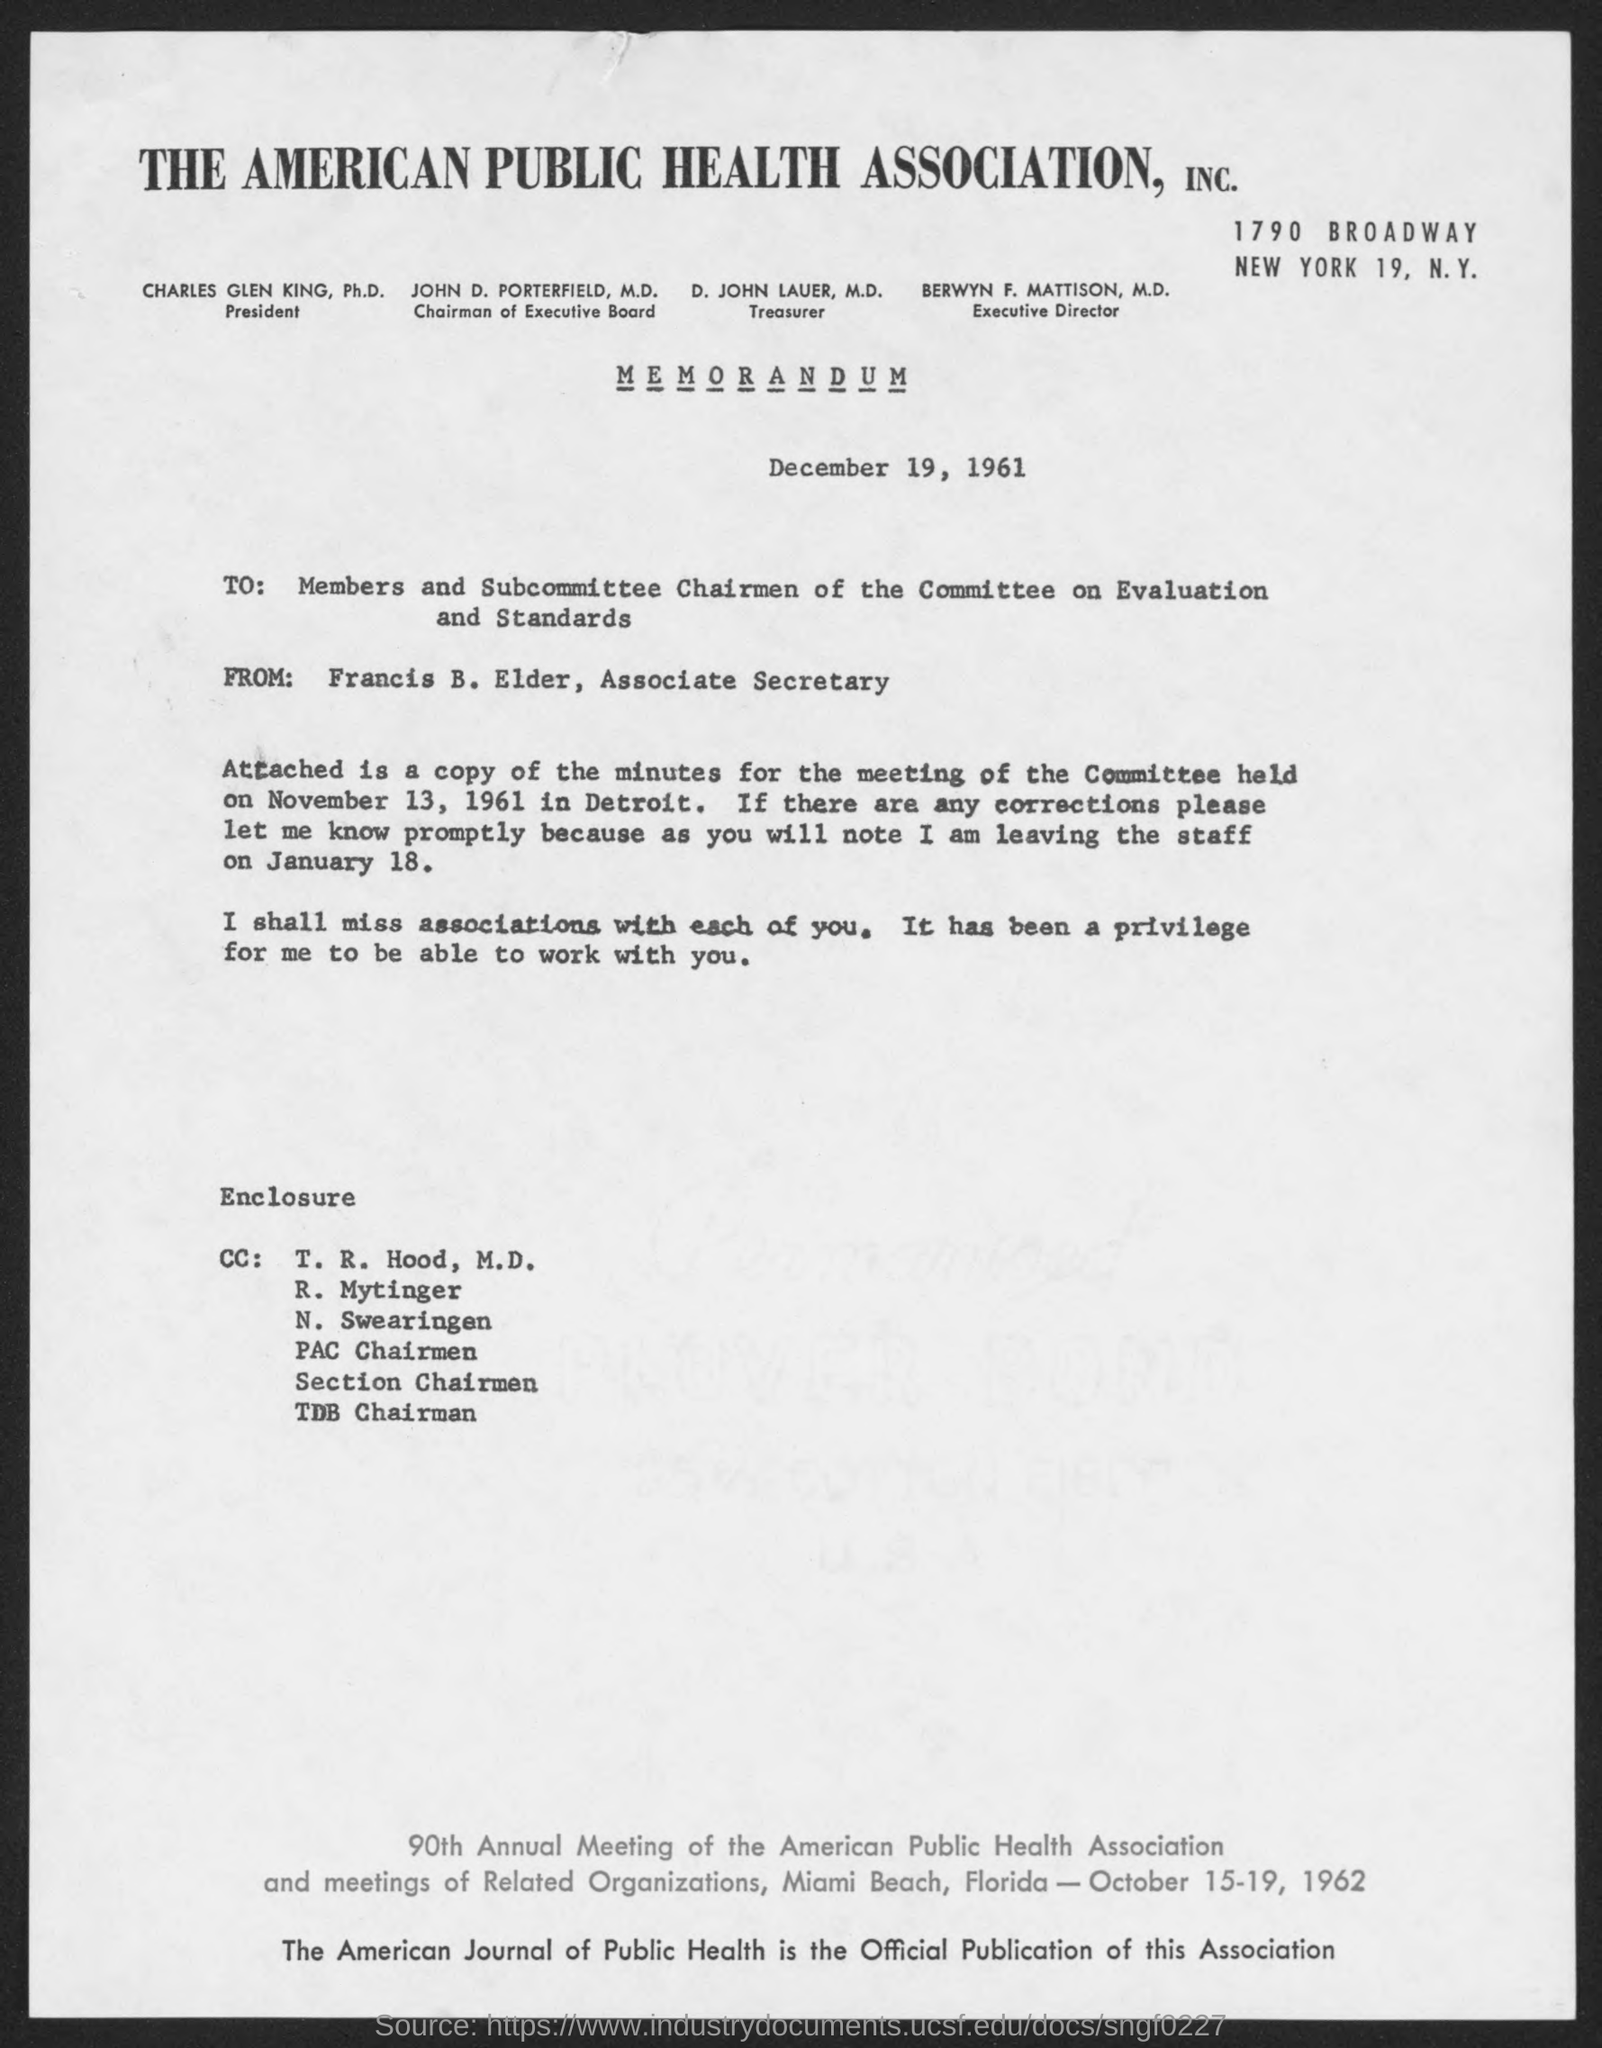What is the street address of the american public health association, inc.?
Give a very brief answer. 1790 Broadway. Who is the president, the american public health association, inc.?
Offer a terse response. Charles Glen King. Who is the chairman of executive board, the american public health association,inc.?
Offer a very short reply. John D. Porterfield. Who is the treasurer, the american public health association, inc.?
Keep it short and to the point. D. John Lauer, M.D. Who is the executive director, the american public health association, inc .?
Your answer should be compact. Berwyn F. Mattison. When is the memorandum dated?
Ensure brevity in your answer.  December 19, 1961. What is the position of francis b. elder ?
Offer a terse response. Associate Secretary. What is the date that the enclosed copy of minutes of meeting is relevant to ?
Ensure brevity in your answer.  November 13, 1961. 